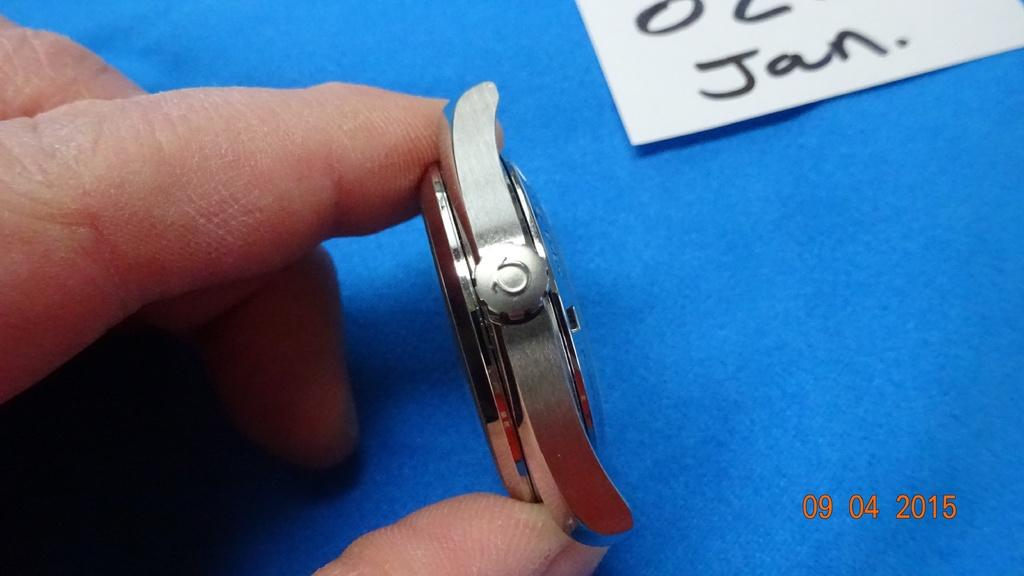<image>
Share a concise interpretation of the image provided. Someone holds a watch case near a paper note that says Jan on it. 